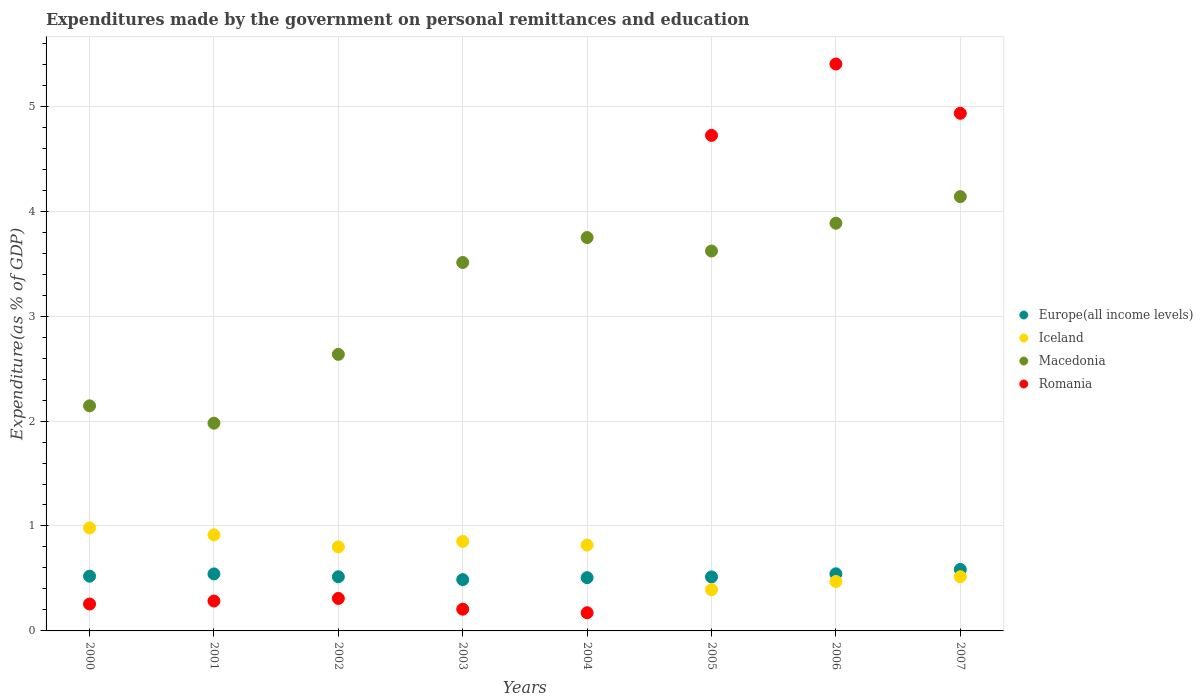How many different coloured dotlines are there?
Offer a terse response. 4. What is the expenditures made by the government on personal remittances and education in Iceland in 2006?
Your answer should be compact. 0.47. Across all years, what is the maximum expenditures made by the government on personal remittances and education in Romania?
Give a very brief answer. 5.4. Across all years, what is the minimum expenditures made by the government on personal remittances and education in Europe(all income levels)?
Your response must be concise. 0.49. In which year was the expenditures made by the government on personal remittances and education in Romania maximum?
Provide a short and direct response. 2006. What is the total expenditures made by the government on personal remittances and education in Europe(all income levels) in the graph?
Give a very brief answer. 4.22. What is the difference between the expenditures made by the government on personal remittances and education in Iceland in 2001 and that in 2007?
Provide a short and direct response. 0.4. What is the difference between the expenditures made by the government on personal remittances and education in Europe(all income levels) in 2003 and the expenditures made by the government on personal remittances and education in Macedonia in 2005?
Keep it short and to the point. -3.13. What is the average expenditures made by the government on personal remittances and education in Macedonia per year?
Give a very brief answer. 3.21. In the year 2001, what is the difference between the expenditures made by the government on personal remittances and education in Romania and expenditures made by the government on personal remittances and education in Europe(all income levels)?
Give a very brief answer. -0.26. In how many years, is the expenditures made by the government on personal remittances and education in Macedonia greater than 2.6 %?
Keep it short and to the point. 6. What is the ratio of the expenditures made by the government on personal remittances and education in Romania in 2001 to that in 2002?
Offer a terse response. 0.92. Is the difference between the expenditures made by the government on personal remittances and education in Romania in 2001 and 2005 greater than the difference between the expenditures made by the government on personal remittances and education in Europe(all income levels) in 2001 and 2005?
Your answer should be compact. No. What is the difference between the highest and the second highest expenditures made by the government on personal remittances and education in Iceland?
Your response must be concise. 0.07. What is the difference between the highest and the lowest expenditures made by the government on personal remittances and education in Iceland?
Give a very brief answer. 0.59. In how many years, is the expenditures made by the government on personal remittances and education in Macedonia greater than the average expenditures made by the government on personal remittances and education in Macedonia taken over all years?
Ensure brevity in your answer.  5. Is the sum of the expenditures made by the government on personal remittances and education in Macedonia in 2001 and 2005 greater than the maximum expenditures made by the government on personal remittances and education in Europe(all income levels) across all years?
Provide a succinct answer. Yes. Is it the case that in every year, the sum of the expenditures made by the government on personal remittances and education in Iceland and expenditures made by the government on personal remittances and education in Romania  is greater than the sum of expenditures made by the government on personal remittances and education in Europe(all income levels) and expenditures made by the government on personal remittances and education in Macedonia?
Your answer should be compact. No. Does the expenditures made by the government on personal remittances and education in Romania monotonically increase over the years?
Give a very brief answer. No. Is the expenditures made by the government on personal remittances and education in Iceland strictly greater than the expenditures made by the government on personal remittances and education in Macedonia over the years?
Your answer should be very brief. No. What is the difference between two consecutive major ticks on the Y-axis?
Your answer should be compact. 1. Are the values on the major ticks of Y-axis written in scientific E-notation?
Your answer should be very brief. No. Does the graph contain any zero values?
Offer a very short reply. No. Does the graph contain grids?
Give a very brief answer. Yes. Where does the legend appear in the graph?
Give a very brief answer. Center right. How are the legend labels stacked?
Your response must be concise. Vertical. What is the title of the graph?
Give a very brief answer. Expenditures made by the government on personal remittances and education. Does "Jordan" appear as one of the legend labels in the graph?
Provide a short and direct response. No. What is the label or title of the X-axis?
Your answer should be very brief. Years. What is the label or title of the Y-axis?
Make the answer very short. Expenditure(as % of GDP). What is the Expenditure(as % of GDP) of Europe(all income levels) in 2000?
Ensure brevity in your answer.  0.52. What is the Expenditure(as % of GDP) in Iceland in 2000?
Ensure brevity in your answer.  0.98. What is the Expenditure(as % of GDP) of Macedonia in 2000?
Offer a terse response. 2.14. What is the Expenditure(as % of GDP) of Romania in 2000?
Your answer should be compact. 0.26. What is the Expenditure(as % of GDP) in Europe(all income levels) in 2001?
Your answer should be very brief. 0.54. What is the Expenditure(as % of GDP) of Iceland in 2001?
Offer a very short reply. 0.92. What is the Expenditure(as % of GDP) in Macedonia in 2001?
Offer a very short reply. 1.98. What is the Expenditure(as % of GDP) in Romania in 2001?
Offer a terse response. 0.28. What is the Expenditure(as % of GDP) in Europe(all income levels) in 2002?
Your response must be concise. 0.52. What is the Expenditure(as % of GDP) in Iceland in 2002?
Your answer should be compact. 0.8. What is the Expenditure(as % of GDP) of Macedonia in 2002?
Make the answer very short. 2.64. What is the Expenditure(as % of GDP) of Romania in 2002?
Your answer should be very brief. 0.31. What is the Expenditure(as % of GDP) in Europe(all income levels) in 2003?
Keep it short and to the point. 0.49. What is the Expenditure(as % of GDP) in Iceland in 2003?
Keep it short and to the point. 0.85. What is the Expenditure(as % of GDP) of Macedonia in 2003?
Offer a very short reply. 3.51. What is the Expenditure(as % of GDP) in Romania in 2003?
Give a very brief answer. 0.21. What is the Expenditure(as % of GDP) of Europe(all income levels) in 2004?
Your response must be concise. 0.51. What is the Expenditure(as % of GDP) of Iceland in 2004?
Your answer should be very brief. 0.82. What is the Expenditure(as % of GDP) of Macedonia in 2004?
Make the answer very short. 3.75. What is the Expenditure(as % of GDP) in Romania in 2004?
Your answer should be compact. 0.17. What is the Expenditure(as % of GDP) of Europe(all income levels) in 2005?
Provide a short and direct response. 0.51. What is the Expenditure(as % of GDP) of Iceland in 2005?
Offer a terse response. 0.39. What is the Expenditure(as % of GDP) of Macedonia in 2005?
Your response must be concise. 3.62. What is the Expenditure(as % of GDP) in Romania in 2005?
Your answer should be compact. 4.72. What is the Expenditure(as % of GDP) of Europe(all income levels) in 2006?
Your answer should be very brief. 0.54. What is the Expenditure(as % of GDP) in Iceland in 2006?
Provide a succinct answer. 0.47. What is the Expenditure(as % of GDP) of Macedonia in 2006?
Your answer should be very brief. 3.88. What is the Expenditure(as % of GDP) in Romania in 2006?
Your answer should be very brief. 5.4. What is the Expenditure(as % of GDP) of Europe(all income levels) in 2007?
Provide a short and direct response. 0.59. What is the Expenditure(as % of GDP) in Iceland in 2007?
Give a very brief answer. 0.52. What is the Expenditure(as % of GDP) of Macedonia in 2007?
Your response must be concise. 4.14. What is the Expenditure(as % of GDP) of Romania in 2007?
Give a very brief answer. 4.93. Across all years, what is the maximum Expenditure(as % of GDP) in Europe(all income levels)?
Provide a succinct answer. 0.59. Across all years, what is the maximum Expenditure(as % of GDP) in Iceland?
Provide a short and direct response. 0.98. Across all years, what is the maximum Expenditure(as % of GDP) of Macedonia?
Offer a terse response. 4.14. Across all years, what is the maximum Expenditure(as % of GDP) in Romania?
Your answer should be very brief. 5.4. Across all years, what is the minimum Expenditure(as % of GDP) in Europe(all income levels)?
Make the answer very short. 0.49. Across all years, what is the minimum Expenditure(as % of GDP) of Iceland?
Keep it short and to the point. 0.39. Across all years, what is the minimum Expenditure(as % of GDP) in Macedonia?
Offer a terse response. 1.98. Across all years, what is the minimum Expenditure(as % of GDP) in Romania?
Offer a very short reply. 0.17. What is the total Expenditure(as % of GDP) in Europe(all income levels) in the graph?
Ensure brevity in your answer.  4.22. What is the total Expenditure(as % of GDP) of Iceland in the graph?
Your answer should be very brief. 5.75. What is the total Expenditure(as % of GDP) of Macedonia in the graph?
Ensure brevity in your answer.  25.66. What is the total Expenditure(as % of GDP) of Romania in the graph?
Give a very brief answer. 16.29. What is the difference between the Expenditure(as % of GDP) of Europe(all income levels) in 2000 and that in 2001?
Ensure brevity in your answer.  -0.02. What is the difference between the Expenditure(as % of GDP) of Iceland in 2000 and that in 2001?
Offer a terse response. 0.07. What is the difference between the Expenditure(as % of GDP) of Macedonia in 2000 and that in 2001?
Keep it short and to the point. 0.17. What is the difference between the Expenditure(as % of GDP) of Romania in 2000 and that in 2001?
Keep it short and to the point. -0.03. What is the difference between the Expenditure(as % of GDP) of Europe(all income levels) in 2000 and that in 2002?
Provide a short and direct response. 0.01. What is the difference between the Expenditure(as % of GDP) in Iceland in 2000 and that in 2002?
Keep it short and to the point. 0.18. What is the difference between the Expenditure(as % of GDP) in Macedonia in 2000 and that in 2002?
Give a very brief answer. -0.49. What is the difference between the Expenditure(as % of GDP) of Romania in 2000 and that in 2002?
Your answer should be compact. -0.05. What is the difference between the Expenditure(as % of GDP) of Europe(all income levels) in 2000 and that in 2003?
Keep it short and to the point. 0.03. What is the difference between the Expenditure(as % of GDP) of Iceland in 2000 and that in 2003?
Your answer should be compact. 0.13. What is the difference between the Expenditure(as % of GDP) in Macedonia in 2000 and that in 2003?
Make the answer very short. -1.37. What is the difference between the Expenditure(as % of GDP) in Romania in 2000 and that in 2003?
Offer a very short reply. 0.05. What is the difference between the Expenditure(as % of GDP) in Europe(all income levels) in 2000 and that in 2004?
Give a very brief answer. 0.01. What is the difference between the Expenditure(as % of GDP) of Iceland in 2000 and that in 2004?
Keep it short and to the point. 0.16. What is the difference between the Expenditure(as % of GDP) of Macedonia in 2000 and that in 2004?
Your answer should be very brief. -1.6. What is the difference between the Expenditure(as % of GDP) of Romania in 2000 and that in 2004?
Ensure brevity in your answer.  0.08. What is the difference between the Expenditure(as % of GDP) in Europe(all income levels) in 2000 and that in 2005?
Ensure brevity in your answer.  0.01. What is the difference between the Expenditure(as % of GDP) in Iceland in 2000 and that in 2005?
Keep it short and to the point. 0.59. What is the difference between the Expenditure(as % of GDP) in Macedonia in 2000 and that in 2005?
Your answer should be very brief. -1.48. What is the difference between the Expenditure(as % of GDP) in Romania in 2000 and that in 2005?
Make the answer very short. -4.47. What is the difference between the Expenditure(as % of GDP) in Europe(all income levels) in 2000 and that in 2006?
Ensure brevity in your answer.  -0.02. What is the difference between the Expenditure(as % of GDP) of Iceland in 2000 and that in 2006?
Make the answer very short. 0.51. What is the difference between the Expenditure(as % of GDP) in Macedonia in 2000 and that in 2006?
Make the answer very short. -1.74. What is the difference between the Expenditure(as % of GDP) in Romania in 2000 and that in 2006?
Make the answer very short. -5.15. What is the difference between the Expenditure(as % of GDP) of Europe(all income levels) in 2000 and that in 2007?
Ensure brevity in your answer.  -0.06. What is the difference between the Expenditure(as % of GDP) of Iceland in 2000 and that in 2007?
Make the answer very short. 0.47. What is the difference between the Expenditure(as % of GDP) of Macedonia in 2000 and that in 2007?
Offer a very short reply. -1.99. What is the difference between the Expenditure(as % of GDP) of Romania in 2000 and that in 2007?
Provide a succinct answer. -4.68. What is the difference between the Expenditure(as % of GDP) of Europe(all income levels) in 2001 and that in 2002?
Your answer should be very brief. 0.03. What is the difference between the Expenditure(as % of GDP) of Iceland in 2001 and that in 2002?
Your answer should be compact. 0.11. What is the difference between the Expenditure(as % of GDP) of Macedonia in 2001 and that in 2002?
Your answer should be compact. -0.66. What is the difference between the Expenditure(as % of GDP) in Romania in 2001 and that in 2002?
Ensure brevity in your answer.  -0.02. What is the difference between the Expenditure(as % of GDP) of Europe(all income levels) in 2001 and that in 2003?
Provide a succinct answer. 0.05. What is the difference between the Expenditure(as % of GDP) of Iceland in 2001 and that in 2003?
Offer a very short reply. 0.06. What is the difference between the Expenditure(as % of GDP) in Macedonia in 2001 and that in 2003?
Your answer should be compact. -1.53. What is the difference between the Expenditure(as % of GDP) of Romania in 2001 and that in 2003?
Give a very brief answer. 0.08. What is the difference between the Expenditure(as % of GDP) in Europe(all income levels) in 2001 and that in 2004?
Ensure brevity in your answer.  0.04. What is the difference between the Expenditure(as % of GDP) of Iceland in 2001 and that in 2004?
Your answer should be very brief. 0.1. What is the difference between the Expenditure(as % of GDP) of Macedonia in 2001 and that in 2004?
Your response must be concise. -1.77. What is the difference between the Expenditure(as % of GDP) of Romania in 2001 and that in 2004?
Give a very brief answer. 0.11. What is the difference between the Expenditure(as % of GDP) of Europe(all income levels) in 2001 and that in 2005?
Your response must be concise. 0.03. What is the difference between the Expenditure(as % of GDP) in Iceland in 2001 and that in 2005?
Give a very brief answer. 0.52. What is the difference between the Expenditure(as % of GDP) of Macedonia in 2001 and that in 2005?
Provide a succinct answer. -1.64. What is the difference between the Expenditure(as % of GDP) in Romania in 2001 and that in 2005?
Provide a short and direct response. -4.44. What is the difference between the Expenditure(as % of GDP) of Europe(all income levels) in 2001 and that in 2006?
Offer a terse response. -0. What is the difference between the Expenditure(as % of GDP) in Iceland in 2001 and that in 2006?
Keep it short and to the point. 0.44. What is the difference between the Expenditure(as % of GDP) in Macedonia in 2001 and that in 2006?
Your answer should be compact. -1.91. What is the difference between the Expenditure(as % of GDP) of Romania in 2001 and that in 2006?
Offer a terse response. -5.12. What is the difference between the Expenditure(as % of GDP) in Europe(all income levels) in 2001 and that in 2007?
Offer a terse response. -0.04. What is the difference between the Expenditure(as % of GDP) of Iceland in 2001 and that in 2007?
Your answer should be very brief. 0.4. What is the difference between the Expenditure(as % of GDP) of Macedonia in 2001 and that in 2007?
Provide a succinct answer. -2.16. What is the difference between the Expenditure(as % of GDP) in Romania in 2001 and that in 2007?
Make the answer very short. -4.65. What is the difference between the Expenditure(as % of GDP) of Europe(all income levels) in 2002 and that in 2003?
Provide a succinct answer. 0.03. What is the difference between the Expenditure(as % of GDP) of Iceland in 2002 and that in 2003?
Your answer should be compact. -0.05. What is the difference between the Expenditure(as % of GDP) of Macedonia in 2002 and that in 2003?
Ensure brevity in your answer.  -0.88. What is the difference between the Expenditure(as % of GDP) in Romania in 2002 and that in 2003?
Offer a very short reply. 0.1. What is the difference between the Expenditure(as % of GDP) of Europe(all income levels) in 2002 and that in 2004?
Offer a very short reply. 0.01. What is the difference between the Expenditure(as % of GDP) in Iceland in 2002 and that in 2004?
Your response must be concise. -0.02. What is the difference between the Expenditure(as % of GDP) in Macedonia in 2002 and that in 2004?
Provide a succinct answer. -1.11. What is the difference between the Expenditure(as % of GDP) of Romania in 2002 and that in 2004?
Your answer should be compact. 0.14. What is the difference between the Expenditure(as % of GDP) in Europe(all income levels) in 2002 and that in 2005?
Your answer should be very brief. 0. What is the difference between the Expenditure(as % of GDP) of Iceland in 2002 and that in 2005?
Your response must be concise. 0.41. What is the difference between the Expenditure(as % of GDP) in Macedonia in 2002 and that in 2005?
Provide a short and direct response. -0.98. What is the difference between the Expenditure(as % of GDP) in Romania in 2002 and that in 2005?
Your response must be concise. -4.41. What is the difference between the Expenditure(as % of GDP) in Europe(all income levels) in 2002 and that in 2006?
Give a very brief answer. -0.03. What is the difference between the Expenditure(as % of GDP) of Iceland in 2002 and that in 2006?
Give a very brief answer. 0.33. What is the difference between the Expenditure(as % of GDP) of Macedonia in 2002 and that in 2006?
Your answer should be compact. -1.25. What is the difference between the Expenditure(as % of GDP) of Romania in 2002 and that in 2006?
Make the answer very short. -5.09. What is the difference between the Expenditure(as % of GDP) in Europe(all income levels) in 2002 and that in 2007?
Provide a succinct answer. -0.07. What is the difference between the Expenditure(as % of GDP) in Iceland in 2002 and that in 2007?
Give a very brief answer. 0.28. What is the difference between the Expenditure(as % of GDP) of Macedonia in 2002 and that in 2007?
Your answer should be compact. -1.5. What is the difference between the Expenditure(as % of GDP) of Romania in 2002 and that in 2007?
Give a very brief answer. -4.62. What is the difference between the Expenditure(as % of GDP) of Europe(all income levels) in 2003 and that in 2004?
Ensure brevity in your answer.  -0.02. What is the difference between the Expenditure(as % of GDP) of Iceland in 2003 and that in 2004?
Keep it short and to the point. 0.03. What is the difference between the Expenditure(as % of GDP) of Macedonia in 2003 and that in 2004?
Give a very brief answer. -0.24. What is the difference between the Expenditure(as % of GDP) of Romania in 2003 and that in 2004?
Your answer should be very brief. 0.03. What is the difference between the Expenditure(as % of GDP) of Europe(all income levels) in 2003 and that in 2005?
Make the answer very short. -0.03. What is the difference between the Expenditure(as % of GDP) in Iceland in 2003 and that in 2005?
Your answer should be very brief. 0.46. What is the difference between the Expenditure(as % of GDP) in Macedonia in 2003 and that in 2005?
Offer a very short reply. -0.11. What is the difference between the Expenditure(as % of GDP) of Romania in 2003 and that in 2005?
Offer a terse response. -4.52. What is the difference between the Expenditure(as % of GDP) of Europe(all income levels) in 2003 and that in 2006?
Give a very brief answer. -0.06. What is the difference between the Expenditure(as % of GDP) of Iceland in 2003 and that in 2006?
Give a very brief answer. 0.38. What is the difference between the Expenditure(as % of GDP) of Macedonia in 2003 and that in 2006?
Ensure brevity in your answer.  -0.37. What is the difference between the Expenditure(as % of GDP) of Romania in 2003 and that in 2006?
Offer a very short reply. -5.2. What is the difference between the Expenditure(as % of GDP) of Europe(all income levels) in 2003 and that in 2007?
Your response must be concise. -0.1. What is the difference between the Expenditure(as % of GDP) in Iceland in 2003 and that in 2007?
Provide a short and direct response. 0.34. What is the difference between the Expenditure(as % of GDP) in Macedonia in 2003 and that in 2007?
Offer a terse response. -0.63. What is the difference between the Expenditure(as % of GDP) in Romania in 2003 and that in 2007?
Provide a succinct answer. -4.73. What is the difference between the Expenditure(as % of GDP) in Europe(all income levels) in 2004 and that in 2005?
Your answer should be compact. -0.01. What is the difference between the Expenditure(as % of GDP) in Iceland in 2004 and that in 2005?
Keep it short and to the point. 0.43. What is the difference between the Expenditure(as % of GDP) of Macedonia in 2004 and that in 2005?
Offer a very short reply. 0.13. What is the difference between the Expenditure(as % of GDP) of Romania in 2004 and that in 2005?
Your answer should be compact. -4.55. What is the difference between the Expenditure(as % of GDP) of Europe(all income levels) in 2004 and that in 2006?
Keep it short and to the point. -0.04. What is the difference between the Expenditure(as % of GDP) in Iceland in 2004 and that in 2006?
Your answer should be compact. 0.35. What is the difference between the Expenditure(as % of GDP) of Macedonia in 2004 and that in 2006?
Make the answer very short. -0.14. What is the difference between the Expenditure(as % of GDP) in Romania in 2004 and that in 2006?
Your answer should be compact. -5.23. What is the difference between the Expenditure(as % of GDP) of Europe(all income levels) in 2004 and that in 2007?
Your answer should be very brief. -0.08. What is the difference between the Expenditure(as % of GDP) of Iceland in 2004 and that in 2007?
Your response must be concise. 0.3. What is the difference between the Expenditure(as % of GDP) in Macedonia in 2004 and that in 2007?
Your answer should be compact. -0.39. What is the difference between the Expenditure(as % of GDP) in Romania in 2004 and that in 2007?
Provide a succinct answer. -4.76. What is the difference between the Expenditure(as % of GDP) of Europe(all income levels) in 2005 and that in 2006?
Offer a terse response. -0.03. What is the difference between the Expenditure(as % of GDP) in Iceland in 2005 and that in 2006?
Offer a very short reply. -0.08. What is the difference between the Expenditure(as % of GDP) in Macedonia in 2005 and that in 2006?
Your response must be concise. -0.26. What is the difference between the Expenditure(as % of GDP) in Romania in 2005 and that in 2006?
Your response must be concise. -0.68. What is the difference between the Expenditure(as % of GDP) of Europe(all income levels) in 2005 and that in 2007?
Make the answer very short. -0.07. What is the difference between the Expenditure(as % of GDP) of Iceland in 2005 and that in 2007?
Provide a short and direct response. -0.12. What is the difference between the Expenditure(as % of GDP) in Macedonia in 2005 and that in 2007?
Provide a succinct answer. -0.52. What is the difference between the Expenditure(as % of GDP) in Romania in 2005 and that in 2007?
Keep it short and to the point. -0.21. What is the difference between the Expenditure(as % of GDP) of Europe(all income levels) in 2006 and that in 2007?
Ensure brevity in your answer.  -0.04. What is the difference between the Expenditure(as % of GDP) in Iceland in 2006 and that in 2007?
Your response must be concise. -0.05. What is the difference between the Expenditure(as % of GDP) of Macedonia in 2006 and that in 2007?
Your response must be concise. -0.25. What is the difference between the Expenditure(as % of GDP) in Romania in 2006 and that in 2007?
Keep it short and to the point. 0.47. What is the difference between the Expenditure(as % of GDP) in Europe(all income levels) in 2000 and the Expenditure(as % of GDP) in Iceland in 2001?
Ensure brevity in your answer.  -0.39. What is the difference between the Expenditure(as % of GDP) of Europe(all income levels) in 2000 and the Expenditure(as % of GDP) of Macedonia in 2001?
Your answer should be compact. -1.46. What is the difference between the Expenditure(as % of GDP) of Europe(all income levels) in 2000 and the Expenditure(as % of GDP) of Romania in 2001?
Give a very brief answer. 0.24. What is the difference between the Expenditure(as % of GDP) of Iceland in 2000 and the Expenditure(as % of GDP) of Macedonia in 2001?
Your answer should be compact. -1. What is the difference between the Expenditure(as % of GDP) of Iceland in 2000 and the Expenditure(as % of GDP) of Romania in 2001?
Offer a very short reply. 0.7. What is the difference between the Expenditure(as % of GDP) in Macedonia in 2000 and the Expenditure(as % of GDP) in Romania in 2001?
Your response must be concise. 1.86. What is the difference between the Expenditure(as % of GDP) in Europe(all income levels) in 2000 and the Expenditure(as % of GDP) in Iceland in 2002?
Give a very brief answer. -0.28. What is the difference between the Expenditure(as % of GDP) of Europe(all income levels) in 2000 and the Expenditure(as % of GDP) of Macedonia in 2002?
Give a very brief answer. -2.11. What is the difference between the Expenditure(as % of GDP) in Europe(all income levels) in 2000 and the Expenditure(as % of GDP) in Romania in 2002?
Your response must be concise. 0.21. What is the difference between the Expenditure(as % of GDP) of Iceland in 2000 and the Expenditure(as % of GDP) of Macedonia in 2002?
Your answer should be compact. -1.65. What is the difference between the Expenditure(as % of GDP) of Iceland in 2000 and the Expenditure(as % of GDP) of Romania in 2002?
Make the answer very short. 0.67. What is the difference between the Expenditure(as % of GDP) of Macedonia in 2000 and the Expenditure(as % of GDP) of Romania in 2002?
Your answer should be very brief. 1.84. What is the difference between the Expenditure(as % of GDP) of Europe(all income levels) in 2000 and the Expenditure(as % of GDP) of Iceland in 2003?
Keep it short and to the point. -0.33. What is the difference between the Expenditure(as % of GDP) in Europe(all income levels) in 2000 and the Expenditure(as % of GDP) in Macedonia in 2003?
Offer a very short reply. -2.99. What is the difference between the Expenditure(as % of GDP) of Europe(all income levels) in 2000 and the Expenditure(as % of GDP) of Romania in 2003?
Your response must be concise. 0.31. What is the difference between the Expenditure(as % of GDP) in Iceland in 2000 and the Expenditure(as % of GDP) in Macedonia in 2003?
Your response must be concise. -2.53. What is the difference between the Expenditure(as % of GDP) of Iceland in 2000 and the Expenditure(as % of GDP) of Romania in 2003?
Offer a very short reply. 0.77. What is the difference between the Expenditure(as % of GDP) of Macedonia in 2000 and the Expenditure(as % of GDP) of Romania in 2003?
Ensure brevity in your answer.  1.94. What is the difference between the Expenditure(as % of GDP) in Europe(all income levels) in 2000 and the Expenditure(as % of GDP) in Iceland in 2004?
Give a very brief answer. -0.3. What is the difference between the Expenditure(as % of GDP) in Europe(all income levels) in 2000 and the Expenditure(as % of GDP) in Macedonia in 2004?
Your response must be concise. -3.23. What is the difference between the Expenditure(as % of GDP) in Europe(all income levels) in 2000 and the Expenditure(as % of GDP) in Romania in 2004?
Make the answer very short. 0.35. What is the difference between the Expenditure(as % of GDP) of Iceland in 2000 and the Expenditure(as % of GDP) of Macedonia in 2004?
Keep it short and to the point. -2.77. What is the difference between the Expenditure(as % of GDP) in Iceland in 2000 and the Expenditure(as % of GDP) in Romania in 2004?
Your response must be concise. 0.81. What is the difference between the Expenditure(as % of GDP) in Macedonia in 2000 and the Expenditure(as % of GDP) in Romania in 2004?
Give a very brief answer. 1.97. What is the difference between the Expenditure(as % of GDP) in Europe(all income levels) in 2000 and the Expenditure(as % of GDP) in Iceland in 2005?
Your answer should be very brief. 0.13. What is the difference between the Expenditure(as % of GDP) in Europe(all income levels) in 2000 and the Expenditure(as % of GDP) in Macedonia in 2005?
Make the answer very short. -3.1. What is the difference between the Expenditure(as % of GDP) in Europe(all income levels) in 2000 and the Expenditure(as % of GDP) in Romania in 2005?
Make the answer very short. -4.2. What is the difference between the Expenditure(as % of GDP) of Iceland in 2000 and the Expenditure(as % of GDP) of Macedonia in 2005?
Keep it short and to the point. -2.64. What is the difference between the Expenditure(as % of GDP) in Iceland in 2000 and the Expenditure(as % of GDP) in Romania in 2005?
Offer a very short reply. -3.74. What is the difference between the Expenditure(as % of GDP) in Macedonia in 2000 and the Expenditure(as % of GDP) in Romania in 2005?
Offer a terse response. -2.58. What is the difference between the Expenditure(as % of GDP) of Europe(all income levels) in 2000 and the Expenditure(as % of GDP) of Iceland in 2006?
Provide a short and direct response. 0.05. What is the difference between the Expenditure(as % of GDP) of Europe(all income levels) in 2000 and the Expenditure(as % of GDP) of Macedonia in 2006?
Your answer should be compact. -3.36. What is the difference between the Expenditure(as % of GDP) of Europe(all income levels) in 2000 and the Expenditure(as % of GDP) of Romania in 2006?
Offer a very short reply. -4.88. What is the difference between the Expenditure(as % of GDP) in Iceland in 2000 and the Expenditure(as % of GDP) in Macedonia in 2006?
Provide a succinct answer. -2.9. What is the difference between the Expenditure(as % of GDP) in Iceland in 2000 and the Expenditure(as % of GDP) in Romania in 2006?
Your response must be concise. -4.42. What is the difference between the Expenditure(as % of GDP) in Macedonia in 2000 and the Expenditure(as % of GDP) in Romania in 2006?
Provide a succinct answer. -3.26. What is the difference between the Expenditure(as % of GDP) of Europe(all income levels) in 2000 and the Expenditure(as % of GDP) of Iceland in 2007?
Your response must be concise. 0.01. What is the difference between the Expenditure(as % of GDP) of Europe(all income levels) in 2000 and the Expenditure(as % of GDP) of Macedonia in 2007?
Make the answer very short. -3.62. What is the difference between the Expenditure(as % of GDP) of Europe(all income levels) in 2000 and the Expenditure(as % of GDP) of Romania in 2007?
Make the answer very short. -4.41. What is the difference between the Expenditure(as % of GDP) in Iceland in 2000 and the Expenditure(as % of GDP) in Macedonia in 2007?
Ensure brevity in your answer.  -3.16. What is the difference between the Expenditure(as % of GDP) of Iceland in 2000 and the Expenditure(as % of GDP) of Romania in 2007?
Provide a short and direct response. -3.95. What is the difference between the Expenditure(as % of GDP) in Macedonia in 2000 and the Expenditure(as % of GDP) in Romania in 2007?
Provide a short and direct response. -2.79. What is the difference between the Expenditure(as % of GDP) in Europe(all income levels) in 2001 and the Expenditure(as % of GDP) in Iceland in 2002?
Provide a short and direct response. -0.26. What is the difference between the Expenditure(as % of GDP) of Europe(all income levels) in 2001 and the Expenditure(as % of GDP) of Macedonia in 2002?
Provide a short and direct response. -2.09. What is the difference between the Expenditure(as % of GDP) in Europe(all income levels) in 2001 and the Expenditure(as % of GDP) in Romania in 2002?
Ensure brevity in your answer.  0.23. What is the difference between the Expenditure(as % of GDP) in Iceland in 2001 and the Expenditure(as % of GDP) in Macedonia in 2002?
Your response must be concise. -1.72. What is the difference between the Expenditure(as % of GDP) in Iceland in 2001 and the Expenditure(as % of GDP) in Romania in 2002?
Make the answer very short. 0.61. What is the difference between the Expenditure(as % of GDP) in Macedonia in 2001 and the Expenditure(as % of GDP) in Romania in 2002?
Your answer should be compact. 1.67. What is the difference between the Expenditure(as % of GDP) in Europe(all income levels) in 2001 and the Expenditure(as % of GDP) in Iceland in 2003?
Make the answer very short. -0.31. What is the difference between the Expenditure(as % of GDP) of Europe(all income levels) in 2001 and the Expenditure(as % of GDP) of Macedonia in 2003?
Give a very brief answer. -2.97. What is the difference between the Expenditure(as % of GDP) of Europe(all income levels) in 2001 and the Expenditure(as % of GDP) of Romania in 2003?
Offer a terse response. 0.34. What is the difference between the Expenditure(as % of GDP) in Iceland in 2001 and the Expenditure(as % of GDP) in Macedonia in 2003?
Ensure brevity in your answer.  -2.6. What is the difference between the Expenditure(as % of GDP) of Iceland in 2001 and the Expenditure(as % of GDP) of Romania in 2003?
Keep it short and to the point. 0.71. What is the difference between the Expenditure(as % of GDP) in Macedonia in 2001 and the Expenditure(as % of GDP) in Romania in 2003?
Offer a very short reply. 1.77. What is the difference between the Expenditure(as % of GDP) in Europe(all income levels) in 2001 and the Expenditure(as % of GDP) in Iceland in 2004?
Give a very brief answer. -0.27. What is the difference between the Expenditure(as % of GDP) in Europe(all income levels) in 2001 and the Expenditure(as % of GDP) in Macedonia in 2004?
Keep it short and to the point. -3.21. What is the difference between the Expenditure(as % of GDP) in Europe(all income levels) in 2001 and the Expenditure(as % of GDP) in Romania in 2004?
Your answer should be compact. 0.37. What is the difference between the Expenditure(as % of GDP) of Iceland in 2001 and the Expenditure(as % of GDP) of Macedonia in 2004?
Ensure brevity in your answer.  -2.83. What is the difference between the Expenditure(as % of GDP) in Iceland in 2001 and the Expenditure(as % of GDP) in Romania in 2004?
Give a very brief answer. 0.74. What is the difference between the Expenditure(as % of GDP) of Macedonia in 2001 and the Expenditure(as % of GDP) of Romania in 2004?
Keep it short and to the point. 1.81. What is the difference between the Expenditure(as % of GDP) of Europe(all income levels) in 2001 and the Expenditure(as % of GDP) of Iceland in 2005?
Make the answer very short. 0.15. What is the difference between the Expenditure(as % of GDP) in Europe(all income levels) in 2001 and the Expenditure(as % of GDP) in Macedonia in 2005?
Your answer should be compact. -3.08. What is the difference between the Expenditure(as % of GDP) in Europe(all income levels) in 2001 and the Expenditure(as % of GDP) in Romania in 2005?
Offer a terse response. -4.18. What is the difference between the Expenditure(as % of GDP) of Iceland in 2001 and the Expenditure(as % of GDP) of Macedonia in 2005?
Ensure brevity in your answer.  -2.7. What is the difference between the Expenditure(as % of GDP) of Iceland in 2001 and the Expenditure(as % of GDP) of Romania in 2005?
Make the answer very short. -3.81. What is the difference between the Expenditure(as % of GDP) in Macedonia in 2001 and the Expenditure(as % of GDP) in Romania in 2005?
Provide a succinct answer. -2.74. What is the difference between the Expenditure(as % of GDP) in Europe(all income levels) in 2001 and the Expenditure(as % of GDP) in Iceland in 2006?
Offer a terse response. 0.07. What is the difference between the Expenditure(as % of GDP) of Europe(all income levels) in 2001 and the Expenditure(as % of GDP) of Macedonia in 2006?
Your answer should be compact. -3.34. What is the difference between the Expenditure(as % of GDP) of Europe(all income levels) in 2001 and the Expenditure(as % of GDP) of Romania in 2006?
Ensure brevity in your answer.  -4.86. What is the difference between the Expenditure(as % of GDP) of Iceland in 2001 and the Expenditure(as % of GDP) of Macedonia in 2006?
Offer a terse response. -2.97. What is the difference between the Expenditure(as % of GDP) in Iceland in 2001 and the Expenditure(as % of GDP) in Romania in 2006?
Make the answer very short. -4.49. What is the difference between the Expenditure(as % of GDP) of Macedonia in 2001 and the Expenditure(as % of GDP) of Romania in 2006?
Ensure brevity in your answer.  -3.42. What is the difference between the Expenditure(as % of GDP) in Europe(all income levels) in 2001 and the Expenditure(as % of GDP) in Iceland in 2007?
Provide a short and direct response. 0.03. What is the difference between the Expenditure(as % of GDP) of Europe(all income levels) in 2001 and the Expenditure(as % of GDP) of Macedonia in 2007?
Your answer should be compact. -3.6. What is the difference between the Expenditure(as % of GDP) in Europe(all income levels) in 2001 and the Expenditure(as % of GDP) in Romania in 2007?
Provide a short and direct response. -4.39. What is the difference between the Expenditure(as % of GDP) of Iceland in 2001 and the Expenditure(as % of GDP) of Macedonia in 2007?
Give a very brief answer. -3.22. What is the difference between the Expenditure(as % of GDP) of Iceland in 2001 and the Expenditure(as % of GDP) of Romania in 2007?
Your response must be concise. -4.02. What is the difference between the Expenditure(as % of GDP) in Macedonia in 2001 and the Expenditure(as % of GDP) in Romania in 2007?
Offer a very short reply. -2.95. What is the difference between the Expenditure(as % of GDP) in Europe(all income levels) in 2002 and the Expenditure(as % of GDP) in Iceland in 2003?
Offer a very short reply. -0.34. What is the difference between the Expenditure(as % of GDP) of Europe(all income levels) in 2002 and the Expenditure(as % of GDP) of Macedonia in 2003?
Your answer should be very brief. -2.99. What is the difference between the Expenditure(as % of GDP) of Europe(all income levels) in 2002 and the Expenditure(as % of GDP) of Romania in 2003?
Ensure brevity in your answer.  0.31. What is the difference between the Expenditure(as % of GDP) of Iceland in 2002 and the Expenditure(as % of GDP) of Macedonia in 2003?
Give a very brief answer. -2.71. What is the difference between the Expenditure(as % of GDP) in Iceland in 2002 and the Expenditure(as % of GDP) in Romania in 2003?
Give a very brief answer. 0.59. What is the difference between the Expenditure(as % of GDP) in Macedonia in 2002 and the Expenditure(as % of GDP) in Romania in 2003?
Ensure brevity in your answer.  2.43. What is the difference between the Expenditure(as % of GDP) of Europe(all income levels) in 2002 and the Expenditure(as % of GDP) of Iceland in 2004?
Your answer should be very brief. -0.3. What is the difference between the Expenditure(as % of GDP) of Europe(all income levels) in 2002 and the Expenditure(as % of GDP) of Macedonia in 2004?
Your answer should be compact. -3.23. What is the difference between the Expenditure(as % of GDP) in Europe(all income levels) in 2002 and the Expenditure(as % of GDP) in Romania in 2004?
Your answer should be compact. 0.34. What is the difference between the Expenditure(as % of GDP) of Iceland in 2002 and the Expenditure(as % of GDP) of Macedonia in 2004?
Provide a succinct answer. -2.95. What is the difference between the Expenditure(as % of GDP) in Iceland in 2002 and the Expenditure(as % of GDP) in Romania in 2004?
Ensure brevity in your answer.  0.63. What is the difference between the Expenditure(as % of GDP) in Macedonia in 2002 and the Expenditure(as % of GDP) in Romania in 2004?
Keep it short and to the point. 2.46. What is the difference between the Expenditure(as % of GDP) of Europe(all income levels) in 2002 and the Expenditure(as % of GDP) of Iceland in 2005?
Provide a succinct answer. 0.12. What is the difference between the Expenditure(as % of GDP) of Europe(all income levels) in 2002 and the Expenditure(as % of GDP) of Macedonia in 2005?
Make the answer very short. -3.1. What is the difference between the Expenditure(as % of GDP) in Europe(all income levels) in 2002 and the Expenditure(as % of GDP) in Romania in 2005?
Provide a succinct answer. -4.21. What is the difference between the Expenditure(as % of GDP) in Iceland in 2002 and the Expenditure(as % of GDP) in Macedonia in 2005?
Your answer should be very brief. -2.82. What is the difference between the Expenditure(as % of GDP) of Iceland in 2002 and the Expenditure(as % of GDP) of Romania in 2005?
Offer a terse response. -3.92. What is the difference between the Expenditure(as % of GDP) of Macedonia in 2002 and the Expenditure(as % of GDP) of Romania in 2005?
Offer a terse response. -2.09. What is the difference between the Expenditure(as % of GDP) in Europe(all income levels) in 2002 and the Expenditure(as % of GDP) in Iceland in 2006?
Your answer should be compact. 0.04. What is the difference between the Expenditure(as % of GDP) in Europe(all income levels) in 2002 and the Expenditure(as % of GDP) in Macedonia in 2006?
Offer a very short reply. -3.37. What is the difference between the Expenditure(as % of GDP) in Europe(all income levels) in 2002 and the Expenditure(as % of GDP) in Romania in 2006?
Your response must be concise. -4.89. What is the difference between the Expenditure(as % of GDP) in Iceland in 2002 and the Expenditure(as % of GDP) in Macedonia in 2006?
Provide a short and direct response. -3.08. What is the difference between the Expenditure(as % of GDP) of Iceland in 2002 and the Expenditure(as % of GDP) of Romania in 2006?
Make the answer very short. -4.6. What is the difference between the Expenditure(as % of GDP) in Macedonia in 2002 and the Expenditure(as % of GDP) in Romania in 2006?
Give a very brief answer. -2.77. What is the difference between the Expenditure(as % of GDP) of Europe(all income levels) in 2002 and the Expenditure(as % of GDP) of Iceland in 2007?
Your answer should be compact. -0. What is the difference between the Expenditure(as % of GDP) in Europe(all income levels) in 2002 and the Expenditure(as % of GDP) in Macedonia in 2007?
Ensure brevity in your answer.  -3.62. What is the difference between the Expenditure(as % of GDP) of Europe(all income levels) in 2002 and the Expenditure(as % of GDP) of Romania in 2007?
Your answer should be compact. -4.42. What is the difference between the Expenditure(as % of GDP) of Iceland in 2002 and the Expenditure(as % of GDP) of Macedonia in 2007?
Provide a succinct answer. -3.34. What is the difference between the Expenditure(as % of GDP) in Iceland in 2002 and the Expenditure(as % of GDP) in Romania in 2007?
Make the answer very short. -4.13. What is the difference between the Expenditure(as % of GDP) in Macedonia in 2002 and the Expenditure(as % of GDP) in Romania in 2007?
Give a very brief answer. -2.3. What is the difference between the Expenditure(as % of GDP) in Europe(all income levels) in 2003 and the Expenditure(as % of GDP) in Iceland in 2004?
Make the answer very short. -0.33. What is the difference between the Expenditure(as % of GDP) of Europe(all income levels) in 2003 and the Expenditure(as % of GDP) of Macedonia in 2004?
Provide a succinct answer. -3.26. What is the difference between the Expenditure(as % of GDP) of Europe(all income levels) in 2003 and the Expenditure(as % of GDP) of Romania in 2004?
Offer a terse response. 0.32. What is the difference between the Expenditure(as % of GDP) of Iceland in 2003 and the Expenditure(as % of GDP) of Macedonia in 2004?
Provide a short and direct response. -2.9. What is the difference between the Expenditure(as % of GDP) in Iceland in 2003 and the Expenditure(as % of GDP) in Romania in 2004?
Keep it short and to the point. 0.68. What is the difference between the Expenditure(as % of GDP) of Macedonia in 2003 and the Expenditure(as % of GDP) of Romania in 2004?
Keep it short and to the point. 3.34. What is the difference between the Expenditure(as % of GDP) in Europe(all income levels) in 2003 and the Expenditure(as % of GDP) in Iceland in 2005?
Give a very brief answer. 0.1. What is the difference between the Expenditure(as % of GDP) in Europe(all income levels) in 2003 and the Expenditure(as % of GDP) in Macedonia in 2005?
Offer a very short reply. -3.13. What is the difference between the Expenditure(as % of GDP) of Europe(all income levels) in 2003 and the Expenditure(as % of GDP) of Romania in 2005?
Provide a succinct answer. -4.23. What is the difference between the Expenditure(as % of GDP) of Iceland in 2003 and the Expenditure(as % of GDP) of Macedonia in 2005?
Make the answer very short. -2.77. What is the difference between the Expenditure(as % of GDP) of Iceland in 2003 and the Expenditure(as % of GDP) of Romania in 2005?
Offer a very short reply. -3.87. What is the difference between the Expenditure(as % of GDP) in Macedonia in 2003 and the Expenditure(as % of GDP) in Romania in 2005?
Your answer should be very brief. -1.21. What is the difference between the Expenditure(as % of GDP) in Europe(all income levels) in 2003 and the Expenditure(as % of GDP) in Iceland in 2006?
Make the answer very short. 0.02. What is the difference between the Expenditure(as % of GDP) of Europe(all income levels) in 2003 and the Expenditure(as % of GDP) of Macedonia in 2006?
Provide a succinct answer. -3.4. What is the difference between the Expenditure(as % of GDP) in Europe(all income levels) in 2003 and the Expenditure(as % of GDP) in Romania in 2006?
Offer a very short reply. -4.91. What is the difference between the Expenditure(as % of GDP) in Iceland in 2003 and the Expenditure(as % of GDP) in Macedonia in 2006?
Keep it short and to the point. -3.03. What is the difference between the Expenditure(as % of GDP) in Iceland in 2003 and the Expenditure(as % of GDP) in Romania in 2006?
Provide a succinct answer. -4.55. What is the difference between the Expenditure(as % of GDP) in Macedonia in 2003 and the Expenditure(as % of GDP) in Romania in 2006?
Offer a very short reply. -1.89. What is the difference between the Expenditure(as % of GDP) of Europe(all income levels) in 2003 and the Expenditure(as % of GDP) of Iceland in 2007?
Ensure brevity in your answer.  -0.03. What is the difference between the Expenditure(as % of GDP) in Europe(all income levels) in 2003 and the Expenditure(as % of GDP) in Macedonia in 2007?
Your answer should be very brief. -3.65. What is the difference between the Expenditure(as % of GDP) in Europe(all income levels) in 2003 and the Expenditure(as % of GDP) in Romania in 2007?
Provide a short and direct response. -4.44. What is the difference between the Expenditure(as % of GDP) of Iceland in 2003 and the Expenditure(as % of GDP) of Macedonia in 2007?
Ensure brevity in your answer.  -3.29. What is the difference between the Expenditure(as % of GDP) of Iceland in 2003 and the Expenditure(as % of GDP) of Romania in 2007?
Provide a short and direct response. -4.08. What is the difference between the Expenditure(as % of GDP) of Macedonia in 2003 and the Expenditure(as % of GDP) of Romania in 2007?
Provide a short and direct response. -1.42. What is the difference between the Expenditure(as % of GDP) of Europe(all income levels) in 2004 and the Expenditure(as % of GDP) of Iceland in 2005?
Provide a succinct answer. 0.12. What is the difference between the Expenditure(as % of GDP) of Europe(all income levels) in 2004 and the Expenditure(as % of GDP) of Macedonia in 2005?
Your answer should be compact. -3.11. What is the difference between the Expenditure(as % of GDP) of Europe(all income levels) in 2004 and the Expenditure(as % of GDP) of Romania in 2005?
Your response must be concise. -4.21. What is the difference between the Expenditure(as % of GDP) of Iceland in 2004 and the Expenditure(as % of GDP) of Macedonia in 2005?
Ensure brevity in your answer.  -2.8. What is the difference between the Expenditure(as % of GDP) of Iceland in 2004 and the Expenditure(as % of GDP) of Romania in 2005?
Provide a succinct answer. -3.9. What is the difference between the Expenditure(as % of GDP) in Macedonia in 2004 and the Expenditure(as % of GDP) in Romania in 2005?
Your response must be concise. -0.97. What is the difference between the Expenditure(as % of GDP) of Europe(all income levels) in 2004 and the Expenditure(as % of GDP) of Iceland in 2006?
Provide a succinct answer. 0.04. What is the difference between the Expenditure(as % of GDP) in Europe(all income levels) in 2004 and the Expenditure(as % of GDP) in Macedonia in 2006?
Provide a succinct answer. -3.38. What is the difference between the Expenditure(as % of GDP) of Europe(all income levels) in 2004 and the Expenditure(as % of GDP) of Romania in 2006?
Keep it short and to the point. -4.89. What is the difference between the Expenditure(as % of GDP) of Iceland in 2004 and the Expenditure(as % of GDP) of Macedonia in 2006?
Your response must be concise. -3.07. What is the difference between the Expenditure(as % of GDP) in Iceland in 2004 and the Expenditure(as % of GDP) in Romania in 2006?
Your response must be concise. -4.58. What is the difference between the Expenditure(as % of GDP) of Macedonia in 2004 and the Expenditure(as % of GDP) of Romania in 2006?
Keep it short and to the point. -1.65. What is the difference between the Expenditure(as % of GDP) in Europe(all income levels) in 2004 and the Expenditure(as % of GDP) in Iceland in 2007?
Your answer should be very brief. -0.01. What is the difference between the Expenditure(as % of GDP) in Europe(all income levels) in 2004 and the Expenditure(as % of GDP) in Macedonia in 2007?
Make the answer very short. -3.63. What is the difference between the Expenditure(as % of GDP) of Europe(all income levels) in 2004 and the Expenditure(as % of GDP) of Romania in 2007?
Offer a very short reply. -4.42. What is the difference between the Expenditure(as % of GDP) of Iceland in 2004 and the Expenditure(as % of GDP) of Macedonia in 2007?
Your answer should be very brief. -3.32. What is the difference between the Expenditure(as % of GDP) of Iceland in 2004 and the Expenditure(as % of GDP) of Romania in 2007?
Give a very brief answer. -4.11. What is the difference between the Expenditure(as % of GDP) of Macedonia in 2004 and the Expenditure(as % of GDP) of Romania in 2007?
Provide a succinct answer. -1.18. What is the difference between the Expenditure(as % of GDP) in Europe(all income levels) in 2005 and the Expenditure(as % of GDP) in Iceland in 2006?
Your answer should be very brief. 0.04. What is the difference between the Expenditure(as % of GDP) of Europe(all income levels) in 2005 and the Expenditure(as % of GDP) of Macedonia in 2006?
Offer a very short reply. -3.37. What is the difference between the Expenditure(as % of GDP) in Europe(all income levels) in 2005 and the Expenditure(as % of GDP) in Romania in 2006?
Provide a short and direct response. -4.89. What is the difference between the Expenditure(as % of GDP) of Iceland in 2005 and the Expenditure(as % of GDP) of Macedonia in 2006?
Provide a short and direct response. -3.49. What is the difference between the Expenditure(as % of GDP) of Iceland in 2005 and the Expenditure(as % of GDP) of Romania in 2006?
Keep it short and to the point. -5.01. What is the difference between the Expenditure(as % of GDP) of Macedonia in 2005 and the Expenditure(as % of GDP) of Romania in 2006?
Keep it short and to the point. -1.78. What is the difference between the Expenditure(as % of GDP) of Europe(all income levels) in 2005 and the Expenditure(as % of GDP) of Iceland in 2007?
Your answer should be compact. -0. What is the difference between the Expenditure(as % of GDP) in Europe(all income levels) in 2005 and the Expenditure(as % of GDP) in Macedonia in 2007?
Give a very brief answer. -3.62. What is the difference between the Expenditure(as % of GDP) in Europe(all income levels) in 2005 and the Expenditure(as % of GDP) in Romania in 2007?
Your response must be concise. -4.42. What is the difference between the Expenditure(as % of GDP) of Iceland in 2005 and the Expenditure(as % of GDP) of Macedonia in 2007?
Offer a very short reply. -3.75. What is the difference between the Expenditure(as % of GDP) of Iceland in 2005 and the Expenditure(as % of GDP) of Romania in 2007?
Your answer should be compact. -4.54. What is the difference between the Expenditure(as % of GDP) in Macedonia in 2005 and the Expenditure(as % of GDP) in Romania in 2007?
Give a very brief answer. -1.31. What is the difference between the Expenditure(as % of GDP) of Europe(all income levels) in 2006 and the Expenditure(as % of GDP) of Iceland in 2007?
Ensure brevity in your answer.  0.03. What is the difference between the Expenditure(as % of GDP) in Europe(all income levels) in 2006 and the Expenditure(as % of GDP) in Macedonia in 2007?
Give a very brief answer. -3.59. What is the difference between the Expenditure(as % of GDP) in Europe(all income levels) in 2006 and the Expenditure(as % of GDP) in Romania in 2007?
Ensure brevity in your answer.  -4.39. What is the difference between the Expenditure(as % of GDP) in Iceland in 2006 and the Expenditure(as % of GDP) in Macedonia in 2007?
Provide a short and direct response. -3.67. What is the difference between the Expenditure(as % of GDP) of Iceland in 2006 and the Expenditure(as % of GDP) of Romania in 2007?
Provide a succinct answer. -4.46. What is the difference between the Expenditure(as % of GDP) in Macedonia in 2006 and the Expenditure(as % of GDP) in Romania in 2007?
Offer a terse response. -1.05. What is the average Expenditure(as % of GDP) in Europe(all income levels) per year?
Your response must be concise. 0.53. What is the average Expenditure(as % of GDP) of Iceland per year?
Make the answer very short. 0.72. What is the average Expenditure(as % of GDP) of Macedonia per year?
Offer a very short reply. 3.21. What is the average Expenditure(as % of GDP) of Romania per year?
Keep it short and to the point. 2.04. In the year 2000, what is the difference between the Expenditure(as % of GDP) of Europe(all income levels) and Expenditure(as % of GDP) of Iceland?
Offer a very short reply. -0.46. In the year 2000, what is the difference between the Expenditure(as % of GDP) in Europe(all income levels) and Expenditure(as % of GDP) in Macedonia?
Your response must be concise. -1.62. In the year 2000, what is the difference between the Expenditure(as % of GDP) of Europe(all income levels) and Expenditure(as % of GDP) of Romania?
Your answer should be very brief. 0.27. In the year 2000, what is the difference between the Expenditure(as % of GDP) in Iceland and Expenditure(as % of GDP) in Macedonia?
Offer a terse response. -1.16. In the year 2000, what is the difference between the Expenditure(as % of GDP) in Iceland and Expenditure(as % of GDP) in Romania?
Your answer should be compact. 0.73. In the year 2000, what is the difference between the Expenditure(as % of GDP) in Macedonia and Expenditure(as % of GDP) in Romania?
Give a very brief answer. 1.89. In the year 2001, what is the difference between the Expenditure(as % of GDP) of Europe(all income levels) and Expenditure(as % of GDP) of Iceland?
Provide a short and direct response. -0.37. In the year 2001, what is the difference between the Expenditure(as % of GDP) of Europe(all income levels) and Expenditure(as % of GDP) of Macedonia?
Offer a very short reply. -1.44. In the year 2001, what is the difference between the Expenditure(as % of GDP) of Europe(all income levels) and Expenditure(as % of GDP) of Romania?
Your answer should be very brief. 0.26. In the year 2001, what is the difference between the Expenditure(as % of GDP) of Iceland and Expenditure(as % of GDP) of Macedonia?
Give a very brief answer. -1.06. In the year 2001, what is the difference between the Expenditure(as % of GDP) of Iceland and Expenditure(as % of GDP) of Romania?
Make the answer very short. 0.63. In the year 2001, what is the difference between the Expenditure(as % of GDP) of Macedonia and Expenditure(as % of GDP) of Romania?
Your answer should be compact. 1.69. In the year 2002, what is the difference between the Expenditure(as % of GDP) in Europe(all income levels) and Expenditure(as % of GDP) in Iceland?
Your response must be concise. -0.28. In the year 2002, what is the difference between the Expenditure(as % of GDP) in Europe(all income levels) and Expenditure(as % of GDP) in Macedonia?
Give a very brief answer. -2.12. In the year 2002, what is the difference between the Expenditure(as % of GDP) in Europe(all income levels) and Expenditure(as % of GDP) in Romania?
Keep it short and to the point. 0.21. In the year 2002, what is the difference between the Expenditure(as % of GDP) of Iceland and Expenditure(as % of GDP) of Macedonia?
Provide a short and direct response. -1.83. In the year 2002, what is the difference between the Expenditure(as % of GDP) in Iceland and Expenditure(as % of GDP) in Romania?
Provide a succinct answer. 0.49. In the year 2002, what is the difference between the Expenditure(as % of GDP) in Macedonia and Expenditure(as % of GDP) in Romania?
Give a very brief answer. 2.33. In the year 2003, what is the difference between the Expenditure(as % of GDP) of Europe(all income levels) and Expenditure(as % of GDP) of Iceland?
Provide a short and direct response. -0.36. In the year 2003, what is the difference between the Expenditure(as % of GDP) in Europe(all income levels) and Expenditure(as % of GDP) in Macedonia?
Provide a short and direct response. -3.02. In the year 2003, what is the difference between the Expenditure(as % of GDP) of Europe(all income levels) and Expenditure(as % of GDP) of Romania?
Ensure brevity in your answer.  0.28. In the year 2003, what is the difference between the Expenditure(as % of GDP) of Iceland and Expenditure(as % of GDP) of Macedonia?
Keep it short and to the point. -2.66. In the year 2003, what is the difference between the Expenditure(as % of GDP) in Iceland and Expenditure(as % of GDP) in Romania?
Give a very brief answer. 0.65. In the year 2003, what is the difference between the Expenditure(as % of GDP) of Macedonia and Expenditure(as % of GDP) of Romania?
Make the answer very short. 3.3. In the year 2004, what is the difference between the Expenditure(as % of GDP) in Europe(all income levels) and Expenditure(as % of GDP) in Iceland?
Give a very brief answer. -0.31. In the year 2004, what is the difference between the Expenditure(as % of GDP) in Europe(all income levels) and Expenditure(as % of GDP) in Macedonia?
Give a very brief answer. -3.24. In the year 2004, what is the difference between the Expenditure(as % of GDP) in Europe(all income levels) and Expenditure(as % of GDP) in Romania?
Your answer should be compact. 0.33. In the year 2004, what is the difference between the Expenditure(as % of GDP) in Iceland and Expenditure(as % of GDP) in Macedonia?
Offer a terse response. -2.93. In the year 2004, what is the difference between the Expenditure(as % of GDP) in Iceland and Expenditure(as % of GDP) in Romania?
Make the answer very short. 0.64. In the year 2004, what is the difference between the Expenditure(as % of GDP) in Macedonia and Expenditure(as % of GDP) in Romania?
Provide a short and direct response. 3.58. In the year 2005, what is the difference between the Expenditure(as % of GDP) of Europe(all income levels) and Expenditure(as % of GDP) of Iceland?
Give a very brief answer. 0.12. In the year 2005, what is the difference between the Expenditure(as % of GDP) of Europe(all income levels) and Expenditure(as % of GDP) of Macedonia?
Keep it short and to the point. -3.11. In the year 2005, what is the difference between the Expenditure(as % of GDP) in Europe(all income levels) and Expenditure(as % of GDP) in Romania?
Make the answer very short. -4.21. In the year 2005, what is the difference between the Expenditure(as % of GDP) of Iceland and Expenditure(as % of GDP) of Macedonia?
Ensure brevity in your answer.  -3.23. In the year 2005, what is the difference between the Expenditure(as % of GDP) in Iceland and Expenditure(as % of GDP) in Romania?
Give a very brief answer. -4.33. In the year 2005, what is the difference between the Expenditure(as % of GDP) of Macedonia and Expenditure(as % of GDP) of Romania?
Provide a succinct answer. -1.1. In the year 2006, what is the difference between the Expenditure(as % of GDP) of Europe(all income levels) and Expenditure(as % of GDP) of Iceland?
Offer a terse response. 0.07. In the year 2006, what is the difference between the Expenditure(as % of GDP) in Europe(all income levels) and Expenditure(as % of GDP) in Macedonia?
Your response must be concise. -3.34. In the year 2006, what is the difference between the Expenditure(as % of GDP) in Europe(all income levels) and Expenditure(as % of GDP) in Romania?
Ensure brevity in your answer.  -4.86. In the year 2006, what is the difference between the Expenditure(as % of GDP) in Iceland and Expenditure(as % of GDP) in Macedonia?
Offer a terse response. -3.41. In the year 2006, what is the difference between the Expenditure(as % of GDP) in Iceland and Expenditure(as % of GDP) in Romania?
Keep it short and to the point. -4.93. In the year 2006, what is the difference between the Expenditure(as % of GDP) in Macedonia and Expenditure(as % of GDP) in Romania?
Provide a short and direct response. -1.52. In the year 2007, what is the difference between the Expenditure(as % of GDP) of Europe(all income levels) and Expenditure(as % of GDP) of Iceland?
Provide a short and direct response. 0.07. In the year 2007, what is the difference between the Expenditure(as % of GDP) in Europe(all income levels) and Expenditure(as % of GDP) in Macedonia?
Make the answer very short. -3.55. In the year 2007, what is the difference between the Expenditure(as % of GDP) in Europe(all income levels) and Expenditure(as % of GDP) in Romania?
Offer a terse response. -4.35. In the year 2007, what is the difference between the Expenditure(as % of GDP) in Iceland and Expenditure(as % of GDP) in Macedonia?
Offer a terse response. -3.62. In the year 2007, what is the difference between the Expenditure(as % of GDP) in Iceland and Expenditure(as % of GDP) in Romania?
Ensure brevity in your answer.  -4.42. In the year 2007, what is the difference between the Expenditure(as % of GDP) of Macedonia and Expenditure(as % of GDP) of Romania?
Offer a terse response. -0.79. What is the ratio of the Expenditure(as % of GDP) in Europe(all income levels) in 2000 to that in 2001?
Keep it short and to the point. 0.96. What is the ratio of the Expenditure(as % of GDP) of Iceland in 2000 to that in 2001?
Provide a short and direct response. 1.07. What is the ratio of the Expenditure(as % of GDP) in Macedonia in 2000 to that in 2001?
Make the answer very short. 1.08. What is the ratio of the Expenditure(as % of GDP) of Romania in 2000 to that in 2001?
Offer a very short reply. 0.9. What is the ratio of the Expenditure(as % of GDP) of Europe(all income levels) in 2000 to that in 2002?
Offer a terse response. 1.01. What is the ratio of the Expenditure(as % of GDP) in Iceland in 2000 to that in 2002?
Ensure brevity in your answer.  1.23. What is the ratio of the Expenditure(as % of GDP) in Macedonia in 2000 to that in 2002?
Provide a succinct answer. 0.81. What is the ratio of the Expenditure(as % of GDP) of Romania in 2000 to that in 2002?
Make the answer very short. 0.83. What is the ratio of the Expenditure(as % of GDP) in Europe(all income levels) in 2000 to that in 2003?
Keep it short and to the point. 1.07. What is the ratio of the Expenditure(as % of GDP) of Iceland in 2000 to that in 2003?
Offer a terse response. 1.15. What is the ratio of the Expenditure(as % of GDP) in Macedonia in 2000 to that in 2003?
Provide a short and direct response. 0.61. What is the ratio of the Expenditure(as % of GDP) in Romania in 2000 to that in 2003?
Your answer should be compact. 1.24. What is the ratio of the Expenditure(as % of GDP) of Europe(all income levels) in 2000 to that in 2004?
Make the answer very short. 1.03. What is the ratio of the Expenditure(as % of GDP) of Iceland in 2000 to that in 2004?
Give a very brief answer. 1.2. What is the ratio of the Expenditure(as % of GDP) of Macedonia in 2000 to that in 2004?
Your answer should be very brief. 0.57. What is the ratio of the Expenditure(as % of GDP) in Romania in 2000 to that in 2004?
Offer a terse response. 1.48. What is the ratio of the Expenditure(as % of GDP) in Europe(all income levels) in 2000 to that in 2005?
Your answer should be very brief. 1.01. What is the ratio of the Expenditure(as % of GDP) in Iceland in 2000 to that in 2005?
Make the answer very short. 2.5. What is the ratio of the Expenditure(as % of GDP) in Macedonia in 2000 to that in 2005?
Your answer should be compact. 0.59. What is the ratio of the Expenditure(as % of GDP) of Romania in 2000 to that in 2005?
Make the answer very short. 0.05. What is the ratio of the Expenditure(as % of GDP) in Europe(all income levels) in 2000 to that in 2006?
Offer a very short reply. 0.96. What is the ratio of the Expenditure(as % of GDP) in Iceland in 2000 to that in 2006?
Ensure brevity in your answer.  2.08. What is the ratio of the Expenditure(as % of GDP) in Macedonia in 2000 to that in 2006?
Offer a very short reply. 0.55. What is the ratio of the Expenditure(as % of GDP) of Romania in 2000 to that in 2006?
Your answer should be very brief. 0.05. What is the ratio of the Expenditure(as % of GDP) in Europe(all income levels) in 2000 to that in 2007?
Your answer should be compact. 0.89. What is the ratio of the Expenditure(as % of GDP) in Iceland in 2000 to that in 2007?
Keep it short and to the point. 1.9. What is the ratio of the Expenditure(as % of GDP) in Macedonia in 2000 to that in 2007?
Your answer should be very brief. 0.52. What is the ratio of the Expenditure(as % of GDP) of Romania in 2000 to that in 2007?
Ensure brevity in your answer.  0.05. What is the ratio of the Expenditure(as % of GDP) in Europe(all income levels) in 2001 to that in 2002?
Offer a very short reply. 1.05. What is the ratio of the Expenditure(as % of GDP) of Iceland in 2001 to that in 2002?
Offer a very short reply. 1.14. What is the ratio of the Expenditure(as % of GDP) in Macedonia in 2001 to that in 2002?
Provide a succinct answer. 0.75. What is the ratio of the Expenditure(as % of GDP) in Romania in 2001 to that in 2002?
Provide a short and direct response. 0.92. What is the ratio of the Expenditure(as % of GDP) of Europe(all income levels) in 2001 to that in 2003?
Your answer should be compact. 1.11. What is the ratio of the Expenditure(as % of GDP) of Iceland in 2001 to that in 2003?
Give a very brief answer. 1.07. What is the ratio of the Expenditure(as % of GDP) in Macedonia in 2001 to that in 2003?
Provide a short and direct response. 0.56. What is the ratio of the Expenditure(as % of GDP) in Romania in 2001 to that in 2003?
Make the answer very short. 1.38. What is the ratio of the Expenditure(as % of GDP) in Europe(all income levels) in 2001 to that in 2004?
Keep it short and to the point. 1.07. What is the ratio of the Expenditure(as % of GDP) of Iceland in 2001 to that in 2004?
Provide a succinct answer. 1.12. What is the ratio of the Expenditure(as % of GDP) of Macedonia in 2001 to that in 2004?
Offer a terse response. 0.53. What is the ratio of the Expenditure(as % of GDP) in Romania in 2001 to that in 2004?
Offer a terse response. 1.65. What is the ratio of the Expenditure(as % of GDP) in Europe(all income levels) in 2001 to that in 2005?
Ensure brevity in your answer.  1.06. What is the ratio of the Expenditure(as % of GDP) in Iceland in 2001 to that in 2005?
Your answer should be compact. 2.33. What is the ratio of the Expenditure(as % of GDP) of Macedonia in 2001 to that in 2005?
Keep it short and to the point. 0.55. What is the ratio of the Expenditure(as % of GDP) in Romania in 2001 to that in 2005?
Your answer should be compact. 0.06. What is the ratio of the Expenditure(as % of GDP) in Iceland in 2001 to that in 2006?
Your response must be concise. 1.94. What is the ratio of the Expenditure(as % of GDP) of Macedonia in 2001 to that in 2006?
Offer a very short reply. 0.51. What is the ratio of the Expenditure(as % of GDP) of Romania in 2001 to that in 2006?
Provide a short and direct response. 0.05. What is the ratio of the Expenditure(as % of GDP) in Europe(all income levels) in 2001 to that in 2007?
Offer a very short reply. 0.93. What is the ratio of the Expenditure(as % of GDP) of Iceland in 2001 to that in 2007?
Offer a terse response. 1.77. What is the ratio of the Expenditure(as % of GDP) of Macedonia in 2001 to that in 2007?
Ensure brevity in your answer.  0.48. What is the ratio of the Expenditure(as % of GDP) of Romania in 2001 to that in 2007?
Provide a short and direct response. 0.06. What is the ratio of the Expenditure(as % of GDP) of Europe(all income levels) in 2002 to that in 2003?
Make the answer very short. 1.06. What is the ratio of the Expenditure(as % of GDP) in Iceland in 2002 to that in 2003?
Your answer should be compact. 0.94. What is the ratio of the Expenditure(as % of GDP) of Macedonia in 2002 to that in 2003?
Your response must be concise. 0.75. What is the ratio of the Expenditure(as % of GDP) of Romania in 2002 to that in 2003?
Provide a succinct answer. 1.5. What is the ratio of the Expenditure(as % of GDP) in Europe(all income levels) in 2002 to that in 2004?
Your answer should be very brief. 1.02. What is the ratio of the Expenditure(as % of GDP) of Iceland in 2002 to that in 2004?
Keep it short and to the point. 0.98. What is the ratio of the Expenditure(as % of GDP) in Macedonia in 2002 to that in 2004?
Provide a succinct answer. 0.7. What is the ratio of the Expenditure(as % of GDP) in Romania in 2002 to that in 2004?
Ensure brevity in your answer.  1.79. What is the ratio of the Expenditure(as % of GDP) of Iceland in 2002 to that in 2005?
Provide a short and direct response. 2.04. What is the ratio of the Expenditure(as % of GDP) in Macedonia in 2002 to that in 2005?
Offer a very short reply. 0.73. What is the ratio of the Expenditure(as % of GDP) in Romania in 2002 to that in 2005?
Ensure brevity in your answer.  0.07. What is the ratio of the Expenditure(as % of GDP) of Europe(all income levels) in 2002 to that in 2006?
Provide a short and direct response. 0.95. What is the ratio of the Expenditure(as % of GDP) of Iceland in 2002 to that in 2006?
Offer a terse response. 1.7. What is the ratio of the Expenditure(as % of GDP) of Macedonia in 2002 to that in 2006?
Ensure brevity in your answer.  0.68. What is the ratio of the Expenditure(as % of GDP) in Romania in 2002 to that in 2006?
Offer a terse response. 0.06. What is the ratio of the Expenditure(as % of GDP) in Europe(all income levels) in 2002 to that in 2007?
Your answer should be compact. 0.88. What is the ratio of the Expenditure(as % of GDP) of Iceland in 2002 to that in 2007?
Offer a terse response. 1.55. What is the ratio of the Expenditure(as % of GDP) of Macedonia in 2002 to that in 2007?
Keep it short and to the point. 0.64. What is the ratio of the Expenditure(as % of GDP) of Romania in 2002 to that in 2007?
Make the answer very short. 0.06. What is the ratio of the Expenditure(as % of GDP) in Europe(all income levels) in 2003 to that in 2004?
Your answer should be very brief. 0.96. What is the ratio of the Expenditure(as % of GDP) of Iceland in 2003 to that in 2004?
Offer a terse response. 1.04. What is the ratio of the Expenditure(as % of GDP) of Macedonia in 2003 to that in 2004?
Offer a terse response. 0.94. What is the ratio of the Expenditure(as % of GDP) in Romania in 2003 to that in 2004?
Provide a succinct answer. 1.2. What is the ratio of the Expenditure(as % of GDP) in Europe(all income levels) in 2003 to that in 2005?
Provide a short and direct response. 0.95. What is the ratio of the Expenditure(as % of GDP) of Iceland in 2003 to that in 2005?
Provide a short and direct response. 2.17. What is the ratio of the Expenditure(as % of GDP) of Macedonia in 2003 to that in 2005?
Give a very brief answer. 0.97. What is the ratio of the Expenditure(as % of GDP) in Romania in 2003 to that in 2005?
Offer a very short reply. 0.04. What is the ratio of the Expenditure(as % of GDP) in Europe(all income levels) in 2003 to that in 2006?
Make the answer very short. 0.9. What is the ratio of the Expenditure(as % of GDP) in Iceland in 2003 to that in 2006?
Provide a short and direct response. 1.81. What is the ratio of the Expenditure(as % of GDP) in Macedonia in 2003 to that in 2006?
Give a very brief answer. 0.9. What is the ratio of the Expenditure(as % of GDP) of Romania in 2003 to that in 2006?
Your answer should be compact. 0.04. What is the ratio of the Expenditure(as % of GDP) of Europe(all income levels) in 2003 to that in 2007?
Offer a terse response. 0.83. What is the ratio of the Expenditure(as % of GDP) in Iceland in 2003 to that in 2007?
Ensure brevity in your answer.  1.65. What is the ratio of the Expenditure(as % of GDP) of Macedonia in 2003 to that in 2007?
Make the answer very short. 0.85. What is the ratio of the Expenditure(as % of GDP) in Romania in 2003 to that in 2007?
Your answer should be very brief. 0.04. What is the ratio of the Expenditure(as % of GDP) in Europe(all income levels) in 2004 to that in 2005?
Keep it short and to the point. 0.99. What is the ratio of the Expenditure(as % of GDP) of Iceland in 2004 to that in 2005?
Ensure brevity in your answer.  2.08. What is the ratio of the Expenditure(as % of GDP) in Macedonia in 2004 to that in 2005?
Ensure brevity in your answer.  1.04. What is the ratio of the Expenditure(as % of GDP) of Romania in 2004 to that in 2005?
Provide a short and direct response. 0.04. What is the ratio of the Expenditure(as % of GDP) in Europe(all income levels) in 2004 to that in 2006?
Keep it short and to the point. 0.93. What is the ratio of the Expenditure(as % of GDP) of Iceland in 2004 to that in 2006?
Your response must be concise. 1.74. What is the ratio of the Expenditure(as % of GDP) of Macedonia in 2004 to that in 2006?
Offer a terse response. 0.96. What is the ratio of the Expenditure(as % of GDP) of Romania in 2004 to that in 2006?
Ensure brevity in your answer.  0.03. What is the ratio of the Expenditure(as % of GDP) of Europe(all income levels) in 2004 to that in 2007?
Keep it short and to the point. 0.87. What is the ratio of the Expenditure(as % of GDP) of Iceland in 2004 to that in 2007?
Offer a terse response. 1.58. What is the ratio of the Expenditure(as % of GDP) of Macedonia in 2004 to that in 2007?
Offer a terse response. 0.91. What is the ratio of the Expenditure(as % of GDP) of Romania in 2004 to that in 2007?
Give a very brief answer. 0.04. What is the ratio of the Expenditure(as % of GDP) in Europe(all income levels) in 2005 to that in 2006?
Keep it short and to the point. 0.95. What is the ratio of the Expenditure(as % of GDP) of Iceland in 2005 to that in 2006?
Offer a very short reply. 0.83. What is the ratio of the Expenditure(as % of GDP) in Macedonia in 2005 to that in 2006?
Your answer should be compact. 0.93. What is the ratio of the Expenditure(as % of GDP) in Romania in 2005 to that in 2006?
Provide a short and direct response. 0.87. What is the ratio of the Expenditure(as % of GDP) of Europe(all income levels) in 2005 to that in 2007?
Your answer should be compact. 0.88. What is the ratio of the Expenditure(as % of GDP) of Iceland in 2005 to that in 2007?
Ensure brevity in your answer.  0.76. What is the ratio of the Expenditure(as % of GDP) of Macedonia in 2005 to that in 2007?
Give a very brief answer. 0.87. What is the ratio of the Expenditure(as % of GDP) in Romania in 2005 to that in 2007?
Your response must be concise. 0.96. What is the ratio of the Expenditure(as % of GDP) of Europe(all income levels) in 2006 to that in 2007?
Give a very brief answer. 0.93. What is the ratio of the Expenditure(as % of GDP) in Iceland in 2006 to that in 2007?
Your response must be concise. 0.91. What is the ratio of the Expenditure(as % of GDP) in Macedonia in 2006 to that in 2007?
Your answer should be compact. 0.94. What is the ratio of the Expenditure(as % of GDP) in Romania in 2006 to that in 2007?
Ensure brevity in your answer.  1.1. What is the difference between the highest and the second highest Expenditure(as % of GDP) of Europe(all income levels)?
Keep it short and to the point. 0.04. What is the difference between the highest and the second highest Expenditure(as % of GDP) in Iceland?
Provide a succinct answer. 0.07. What is the difference between the highest and the second highest Expenditure(as % of GDP) in Macedonia?
Give a very brief answer. 0.25. What is the difference between the highest and the second highest Expenditure(as % of GDP) in Romania?
Give a very brief answer. 0.47. What is the difference between the highest and the lowest Expenditure(as % of GDP) of Europe(all income levels)?
Provide a short and direct response. 0.1. What is the difference between the highest and the lowest Expenditure(as % of GDP) in Iceland?
Make the answer very short. 0.59. What is the difference between the highest and the lowest Expenditure(as % of GDP) of Macedonia?
Give a very brief answer. 2.16. What is the difference between the highest and the lowest Expenditure(as % of GDP) of Romania?
Provide a short and direct response. 5.23. 